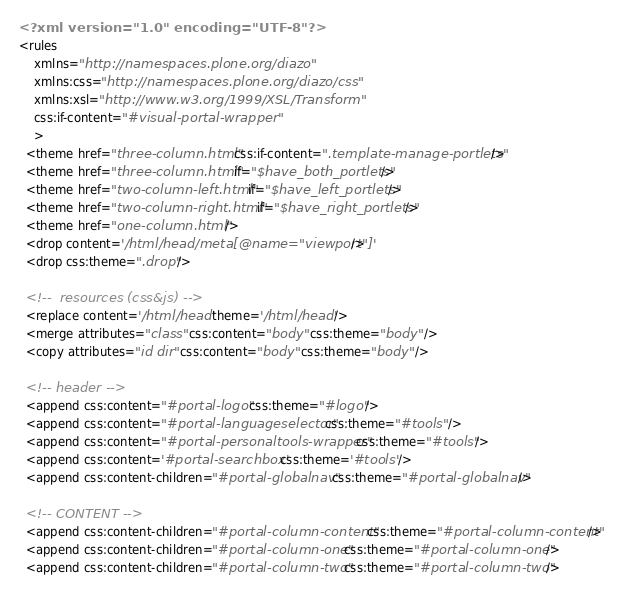Convert code to text. <code><loc_0><loc_0><loc_500><loc_500><_XML_><?xml version="1.0" encoding="UTF-8"?>
<rules
    xmlns="http://namespaces.plone.org/diazo"
    xmlns:css="http://namespaces.plone.org/diazo/css"
    xmlns:xsl="http://www.w3.org/1999/XSL/Transform"
    css:if-content="#visual-portal-wrapper"
    >
  <theme href="three-column.html" css:if-content=".template-manage-portlets"/>
  <theme href="three-column.html" if="$have_both_portlets"/>
  <theme href="two-column-left.html" if="$have_left_portlets"/>
  <theme href="two-column-right.html" if="$have_right_portlets"/>
  <theme href="one-column.html" />
  <drop content='/html/head/meta[@name="viewport"]'/>
  <drop css:theme=".drop"/>

  <!--  resources (css&js) -->
  <replace content='/html/head' theme='/html/head' />
  <merge attributes="class" css:content="body" css:theme="body" />
  <copy attributes="id dir" css:content="body" css:theme="body" />

  <!-- header -->
  <append css:content="#portal-logo" css:theme="#logo"/>
  <append css:content="#portal-languageselector" css:theme="#tools" />
  <append css:content="#portal-personaltools-wrapper" css:theme="#tools"/>
  <append css:content='#portal-searchbox' css:theme='#tools' />
  <append css:content-children="#portal-globalnav" css:theme="#portal-globalnav"/>

  <!-- CONTENT -->
  <append css:content-children="#portal-column-content" css:theme="#portal-column-content"/>
  <append css:content-children="#portal-column-one" css:theme="#portal-column-one" />
  <append css:content-children="#portal-column-two" css:theme="#portal-column-two" /></code> 